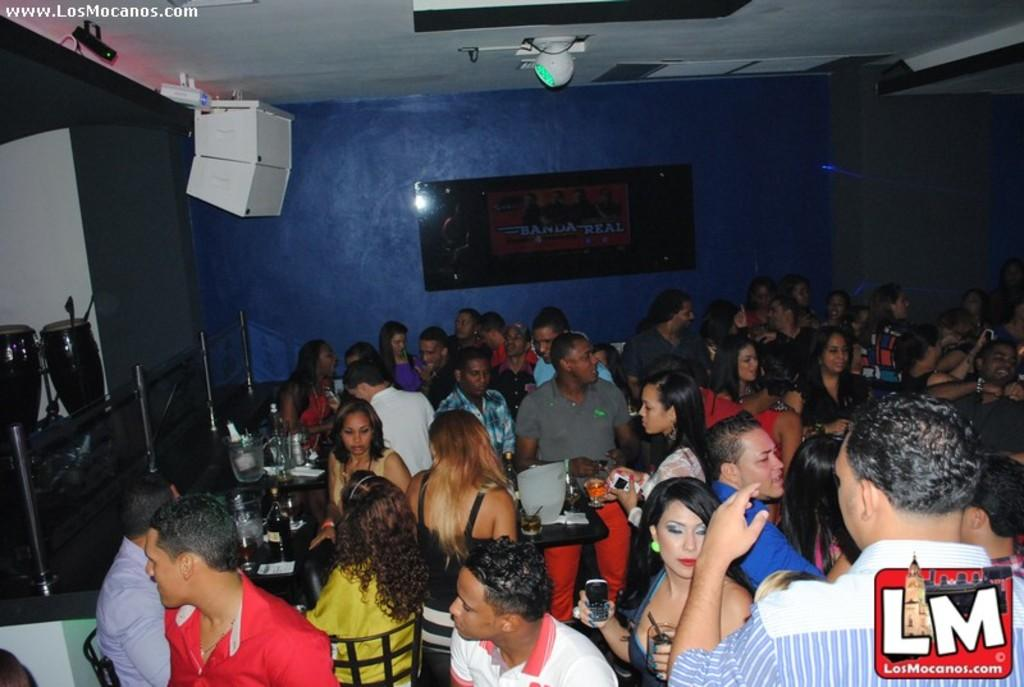Who or what can be seen in the image? There are people in the image. What are the people doing in the image? The people are sitting on chairs. Can you describe any additional features in the image? There are lights on the roof in the image. What type of gun is being used by the people in the image? There is no gun present in the image; the people are sitting on chairs. What disease is affecting the people in the image? There is no indication of any disease affecting the people in the image; they are simply sitting on chairs. 